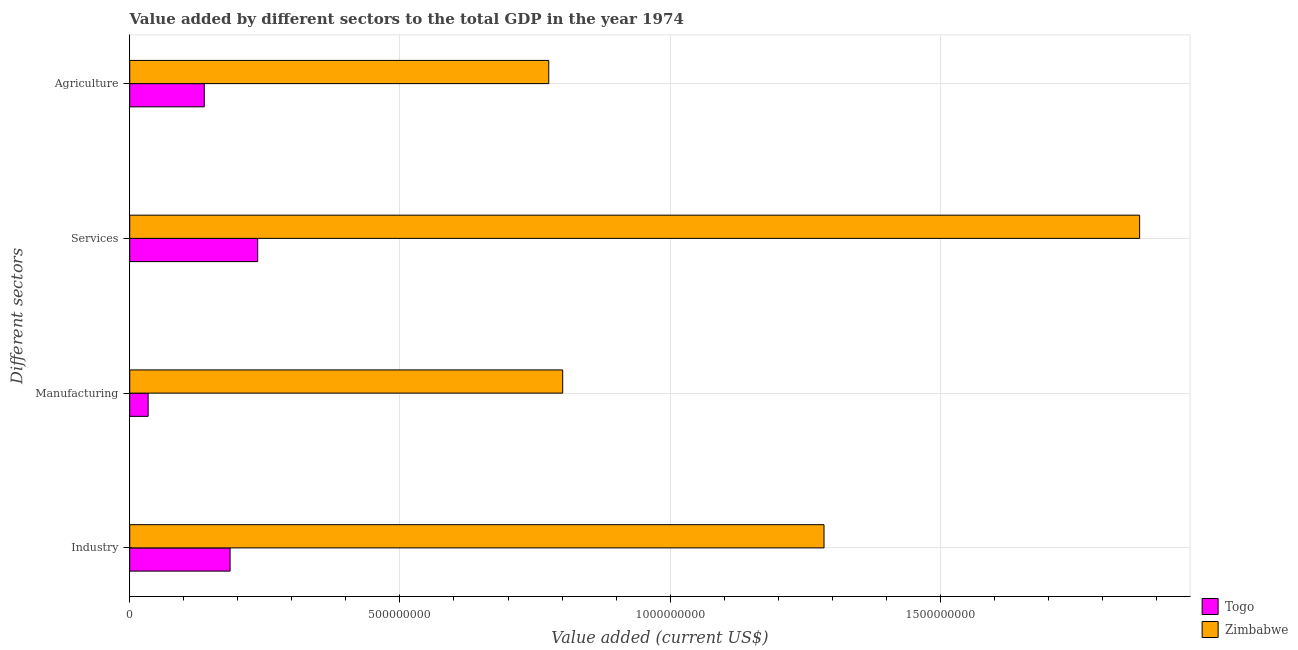Are the number of bars per tick equal to the number of legend labels?
Ensure brevity in your answer.  Yes. How many bars are there on the 4th tick from the bottom?
Make the answer very short. 2. What is the label of the 4th group of bars from the top?
Offer a very short reply. Industry. What is the value added by industrial sector in Zimbabwe?
Make the answer very short. 1.28e+09. Across all countries, what is the maximum value added by services sector?
Your answer should be very brief. 1.87e+09. Across all countries, what is the minimum value added by agricultural sector?
Keep it short and to the point. 1.38e+08. In which country was the value added by industrial sector maximum?
Provide a short and direct response. Zimbabwe. In which country was the value added by services sector minimum?
Ensure brevity in your answer.  Togo. What is the total value added by manufacturing sector in the graph?
Your answer should be very brief. 8.35e+08. What is the difference between the value added by manufacturing sector in Togo and that in Zimbabwe?
Offer a terse response. -7.67e+08. What is the difference between the value added by services sector in Zimbabwe and the value added by industrial sector in Togo?
Your answer should be compact. 1.68e+09. What is the average value added by agricultural sector per country?
Keep it short and to the point. 4.57e+08. What is the difference between the value added by agricultural sector and value added by industrial sector in Zimbabwe?
Provide a short and direct response. -5.09e+08. What is the ratio of the value added by services sector in Zimbabwe to that in Togo?
Your answer should be very brief. 7.89. Is the value added by services sector in Zimbabwe less than that in Togo?
Your answer should be very brief. No. What is the difference between the highest and the second highest value added by industrial sector?
Provide a short and direct response. 1.10e+09. What is the difference between the highest and the lowest value added by agricultural sector?
Your answer should be very brief. 6.37e+08. Is the sum of the value added by agricultural sector in Zimbabwe and Togo greater than the maximum value added by industrial sector across all countries?
Offer a terse response. No. Is it the case that in every country, the sum of the value added by manufacturing sector and value added by services sector is greater than the sum of value added by industrial sector and value added by agricultural sector?
Your answer should be very brief. No. What does the 2nd bar from the top in Services represents?
Make the answer very short. Togo. What does the 2nd bar from the bottom in Industry represents?
Offer a terse response. Zimbabwe. Is it the case that in every country, the sum of the value added by industrial sector and value added by manufacturing sector is greater than the value added by services sector?
Ensure brevity in your answer.  No. Are all the bars in the graph horizontal?
Offer a very short reply. Yes. What is the difference between two consecutive major ticks on the X-axis?
Offer a very short reply. 5.00e+08. Are the values on the major ticks of X-axis written in scientific E-notation?
Give a very brief answer. No. Does the graph contain any zero values?
Your response must be concise. No. Does the graph contain grids?
Your answer should be very brief. Yes. How many legend labels are there?
Provide a short and direct response. 2. What is the title of the graph?
Provide a succinct answer. Value added by different sectors to the total GDP in the year 1974. Does "Thailand" appear as one of the legend labels in the graph?
Offer a very short reply. No. What is the label or title of the X-axis?
Provide a short and direct response. Value added (current US$). What is the label or title of the Y-axis?
Make the answer very short. Different sectors. What is the Value added (current US$) in Togo in Industry?
Your answer should be very brief. 1.86e+08. What is the Value added (current US$) in Zimbabwe in Industry?
Offer a terse response. 1.28e+09. What is the Value added (current US$) of Togo in Manufacturing?
Offer a very short reply. 3.41e+07. What is the Value added (current US$) of Zimbabwe in Manufacturing?
Offer a terse response. 8.01e+08. What is the Value added (current US$) of Togo in Services?
Keep it short and to the point. 2.37e+08. What is the Value added (current US$) of Zimbabwe in Services?
Offer a terse response. 1.87e+09. What is the Value added (current US$) in Togo in Agriculture?
Provide a short and direct response. 1.38e+08. What is the Value added (current US$) of Zimbabwe in Agriculture?
Your answer should be compact. 7.75e+08. Across all Different sectors, what is the maximum Value added (current US$) in Togo?
Your answer should be compact. 2.37e+08. Across all Different sectors, what is the maximum Value added (current US$) of Zimbabwe?
Offer a very short reply. 1.87e+09. Across all Different sectors, what is the minimum Value added (current US$) in Togo?
Make the answer very short. 3.41e+07. Across all Different sectors, what is the minimum Value added (current US$) in Zimbabwe?
Offer a very short reply. 7.75e+08. What is the total Value added (current US$) of Togo in the graph?
Your response must be concise. 5.95e+08. What is the total Value added (current US$) in Zimbabwe in the graph?
Provide a short and direct response. 4.73e+09. What is the difference between the Value added (current US$) of Togo in Industry and that in Manufacturing?
Provide a short and direct response. 1.52e+08. What is the difference between the Value added (current US$) in Zimbabwe in Industry and that in Manufacturing?
Offer a terse response. 4.84e+08. What is the difference between the Value added (current US$) of Togo in Industry and that in Services?
Offer a terse response. -5.11e+07. What is the difference between the Value added (current US$) in Zimbabwe in Industry and that in Services?
Your answer should be very brief. -5.84e+08. What is the difference between the Value added (current US$) of Togo in Industry and that in Agriculture?
Offer a very short reply. 4.78e+07. What is the difference between the Value added (current US$) of Zimbabwe in Industry and that in Agriculture?
Your answer should be very brief. 5.09e+08. What is the difference between the Value added (current US$) in Togo in Manufacturing and that in Services?
Make the answer very short. -2.03e+08. What is the difference between the Value added (current US$) of Zimbabwe in Manufacturing and that in Services?
Your response must be concise. -1.07e+09. What is the difference between the Value added (current US$) in Togo in Manufacturing and that in Agriculture?
Your response must be concise. -1.04e+08. What is the difference between the Value added (current US$) of Zimbabwe in Manufacturing and that in Agriculture?
Your response must be concise. 2.58e+07. What is the difference between the Value added (current US$) in Togo in Services and that in Agriculture?
Offer a very short reply. 9.89e+07. What is the difference between the Value added (current US$) of Zimbabwe in Services and that in Agriculture?
Offer a very short reply. 1.09e+09. What is the difference between the Value added (current US$) of Togo in Industry and the Value added (current US$) of Zimbabwe in Manufacturing?
Provide a short and direct response. -6.15e+08. What is the difference between the Value added (current US$) of Togo in Industry and the Value added (current US$) of Zimbabwe in Services?
Give a very brief answer. -1.68e+09. What is the difference between the Value added (current US$) in Togo in Industry and the Value added (current US$) in Zimbabwe in Agriculture?
Keep it short and to the point. -5.90e+08. What is the difference between the Value added (current US$) in Togo in Manufacturing and the Value added (current US$) in Zimbabwe in Services?
Ensure brevity in your answer.  -1.83e+09. What is the difference between the Value added (current US$) in Togo in Manufacturing and the Value added (current US$) in Zimbabwe in Agriculture?
Your response must be concise. -7.41e+08. What is the difference between the Value added (current US$) in Togo in Services and the Value added (current US$) in Zimbabwe in Agriculture?
Your answer should be compact. -5.39e+08. What is the average Value added (current US$) in Togo per Different sectors?
Your answer should be compact. 1.49e+08. What is the average Value added (current US$) of Zimbabwe per Different sectors?
Provide a short and direct response. 1.18e+09. What is the difference between the Value added (current US$) in Togo and Value added (current US$) in Zimbabwe in Industry?
Keep it short and to the point. -1.10e+09. What is the difference between the Value added (current US$) of Togo and Value added (current US$) of Zimbabwe in Manufacturing?
Your answer should be very brief. -7.67e+08. What is the difference between the Value added (current US$) of Togo and Value added (current US$) of Zimbabwe in Services?
Make the answer very short. -1.63e+09. What is the difference between the Value added (current US$) of Togo and Value added (current US$) of Zimbabwe in Agriculture?
Your answer should be very brief. -6.37e+08. What is the ratio of the Value added (current US$) in Togo in Industry to that in Manufacturing?
Your answer should be compact. 5.45. What is the ratio of the Value added (current US$) of Zimbabwe in Industry to that in Manufacturing?
Offer a very short reply. 1.6. What is the ratio of the Value added (current US$) of Togo in Industry to that in Services?
Keep it short and to the point. 0.78. What is the ratio of the Value added (current US$) in Zimbabwe in Industry to that in Services?
Offer a very short reply. 0.69. What is the ratio of the Value added (current US$) of Togo in Industry to that in Agriculture?
Provide a succinct answer. 1.35. What is the ratio of the Value added (current US$) in Zimbabwe in Industry to that in Agriculture?
Offer a terse response. 1.66. What is the ratio of the Value added (current US$) of Togo in Manufacturing to that in Services?
Offer a very short reply. 0.14. What is the ratio of the Value added (current US$) in Zimbabwe in Manufacturing to that in Services?
Keep it short and to the point. 0.43. What is the ratio of the Value added (current US$) of Togo in Manufacturing to that in Agriculture?
Your response must be concise. 0.25. What is the ratio of the Value added (current US$) of Zimbabwe in Manufacturing to that in Agriculture?
Ensure brevity in your answer.  1.03. What is the ratio of the Value added (current US$) of Togo in Services to that in Agriculture?
Your answer should be compact. 1.72. What is the ratio of the Value added (current US$) of Zimbabwe in Services to that in Agriculture?
Keep it short and to the point. 2.41. What is the difference between the highest and the second highest Value added (current US$) in Togo?
Give a very brief answer. 5.11e+07. What is the difference between the highest and the second highest Value added (current US$) in Zimbabwe?
Offer a terse response. 5.84e+08. What is the difference between the highest and the lowest Value added (current US$) of Togo?
Offer a terse response. 2.03e+08. What is the difference between the highest and the lowest Value added (current US$) in Zimbabwe?
Your answer should be very brief. 1.09e+09. 